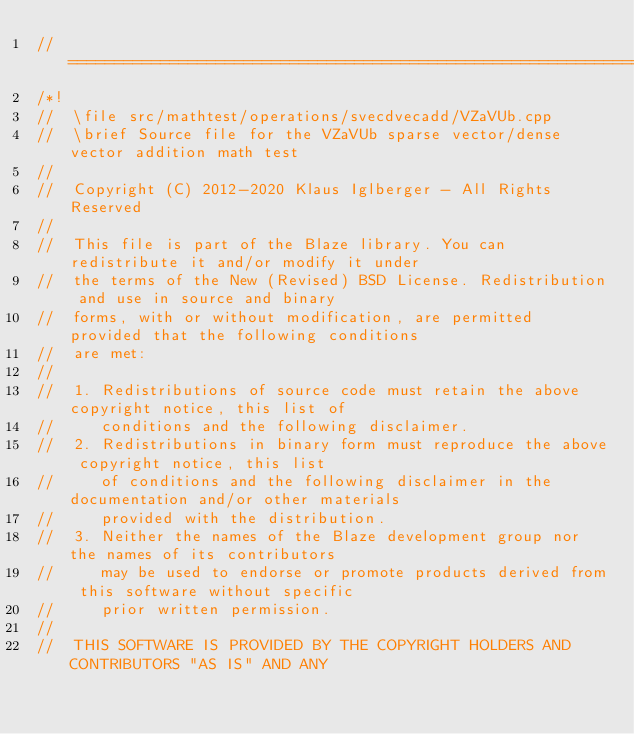Convert code to text. <code><loc_0><loc_0><loc_500><loc_500><_C++_>//=================================================================================================
/*!
//  \file src/mathtest/operations/svecdvecadd/VZaVUb.cpp
//  \brief Source file for the VZaVUb sparse vector/dense vector addition math test
//
//  Copyright (C) 2012-2020 Klaus Iglberger - All Rights Reserved
//
//  This file is part of the Blaze library. You can redistribute it and/or modify it under
//  the terms of the New (Revised) BSD License. Redistribution and use in source and binary
//  forms, with or without modification, are permitted provided that the following conditions
//  are met:
//
//  1. Redistributions of source code must retain the above copyright notice, this list of
//     conditions and the following disclaimer.
//  2. Redistributions in binary form must reproduce the above copyright notice, this list
//     of conditions and the following disclaimer in the documentation and/or other materials
//     provided with the distribution.
//  3. Neither the names of the Blaze development group nor the names of its contributors
//     may be used to endorse or promote products derived from this software without specific
//     prior written permission.
//
//  THIS SOFTWARE IS PROVIDED BY THE COPYRIGHT HOLDERS AND CONTRIBUTORS "AS IS" AND ANY</code> 